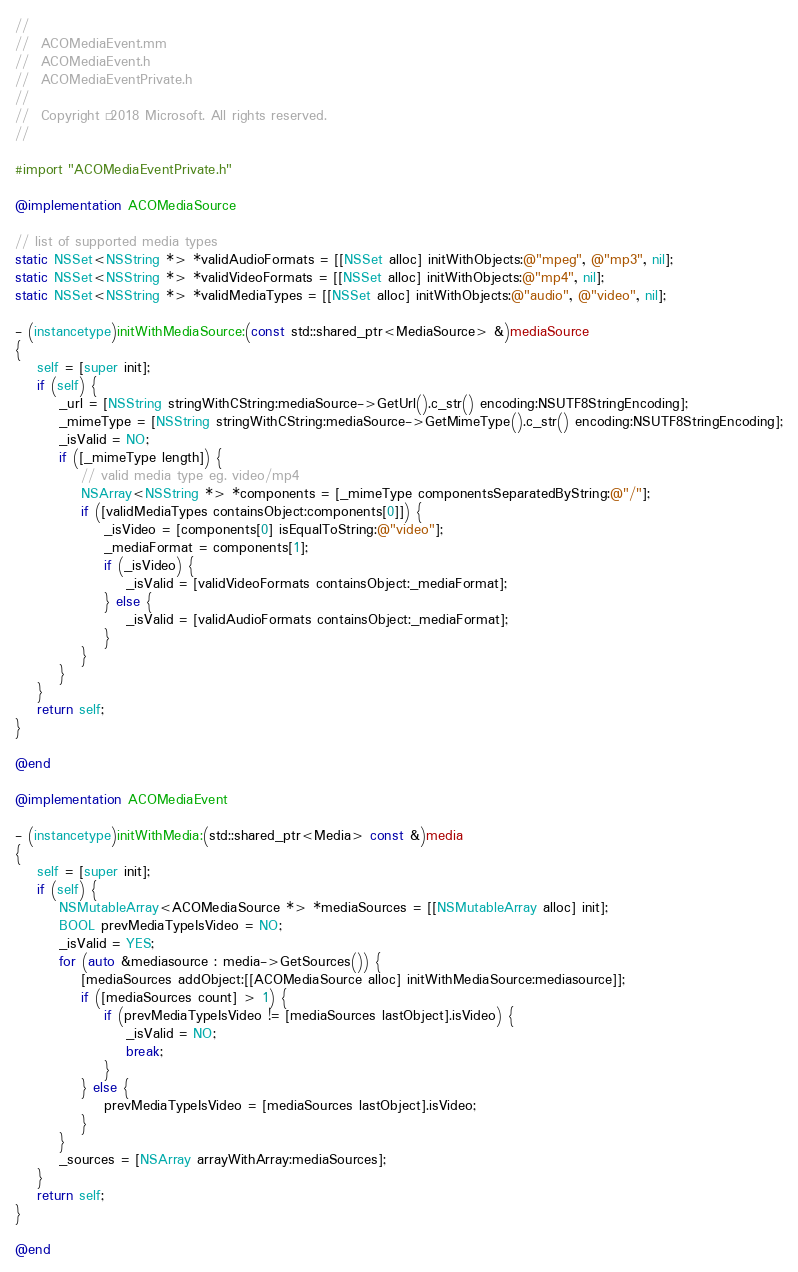Convert code to text. <code><loc_0><loc_0><loc_500><loc_500><_ObjectiveC_>//
//  ACOMediaEvent.mm
//  ACOMediaEvent.h
//  ACOMediaEventPrivate.h
//
//  Copyright © 2018 Microsoft. All rights reserved.
//

#import "ACOMediaEventPrivate.h"

@implementation ACOMediaSource

// list of supported media types
static NSSet<NSString *> *validAudioFormats = [[NSSet alloc] initWithObjects:@"mpeg", @"mp3", nil];
static NSSet<NSString *> *validVideoFormats = [[NSSet alloc] initWithObjects:@"mp4", nil];
static NSSet<NSString *> *validMediaTypes = [[NSSet alloc] initWithObjects:@"audio", @"video", nil];

- (instancetype)initWithMediaSource:(const std::shared_ptr<MediaSource> &)mediaSource
{
    self = [super init];
    if (self) {
        _url = [NSString stringWithCString:mediaSource->GetUrl().c_str() encoding:NSUTF8StringEncoding];
        _mimeType = [NSString stringWithCString:mediaSource->GetMimeType().c_str() encoding:NSUTF8StringEncoding];
        _isValid = NO;
        if ([_mimeType length]) {
            // valid media type eg. video/mp4
            NSArray<NSString *> *components = [_mimeType componentsSeparatedByString:@"/"];
            if ([validMediaTypes containsObject:components[0]]) {
                _isVideo = [components[0] isEqualToString:@"video"];
                _mediaFormat = components[1];
                if (_isVideo) {
                    _isValid = [validVideoFormats containsObject:_mediaFormat];
                } else {
                    _isValid = [validAudioFormats containsObject:_mediaFormat];
                }
            }
        }
    }
    return self;
}

@end

@implementation ACOMediaEvent

- (instancetype)initWithMedia:(std::shared_ptr<Media> const &)media
{
    self = [super init];
    if (self) {
        NSMutableArray<ACOMediaSource *> *mediaSources = [[NSMutableArray alloc] init];
        BOOL prevMediaTypeIsVideo = NO;
        _isValid = YES;
        for (auto &mediasource : media->GetSources()) {
            [mediaSources addObject:[[ACOMediaSource alloc] initWithMediaSource:mediasource]];
            if ([mediaSources count] > 1) {
                if (prevMediaTypeIsVideo != [mediaSources lastObject].isVideo) {
                    _isValid = NO;
                    break;
                }
            } else {
                prevMediaTypeIsVideo = [mediaSources lastObject].isVideo;
            }
        }
        _sources = [NSArray arrayWithArray:mediaSources];
    }
    return self;
}

@end
</code> 